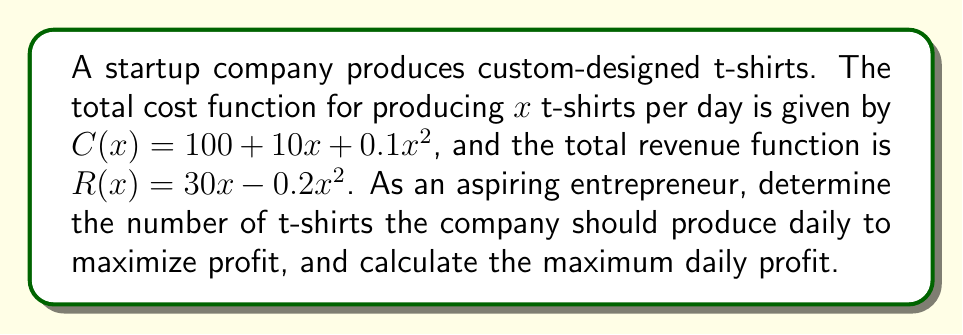Solve this math problem. 1. First, let's find the marginal cost (MC) and marginal revenue (MR) functions:
   
   MC = $\frac{d}{dx}C(x) = 10 + 0.2x$
   MR = $\frac{d}{dx}R(x) = 30 - 0.4x$

2. To maximize profit, we need to find where MC = MR:

   $10 + 0.2x = 30 - 0.4x$
   $0.6x = 20$
   $x = \frac{20}{0.6} \approx 33.33$

   Since we can't produce a fractional number of t-shirts, we round to 33 t-shirts.

3. To calculate the maximum daily profit, we need to find the profit function:

   $P(x) = R(x) - C(x) = (30x - 0.2x^2) - (100 + 10x + 0.1x^2)$
   $P(x) = -0.3x^2 + 20x - 100$

4. Now, let's calculate the profit at x = 33:

   $P(33) = -0.3(33)^2 + 20(33) - 100$
   $= -326.7 + 660 - 100$
   $= 233.3$

Therefore, the maximum daily profit is approximately $233.30.
Answer: Produce 33 t-shirts daily; maximum profit ≈ $233.30 